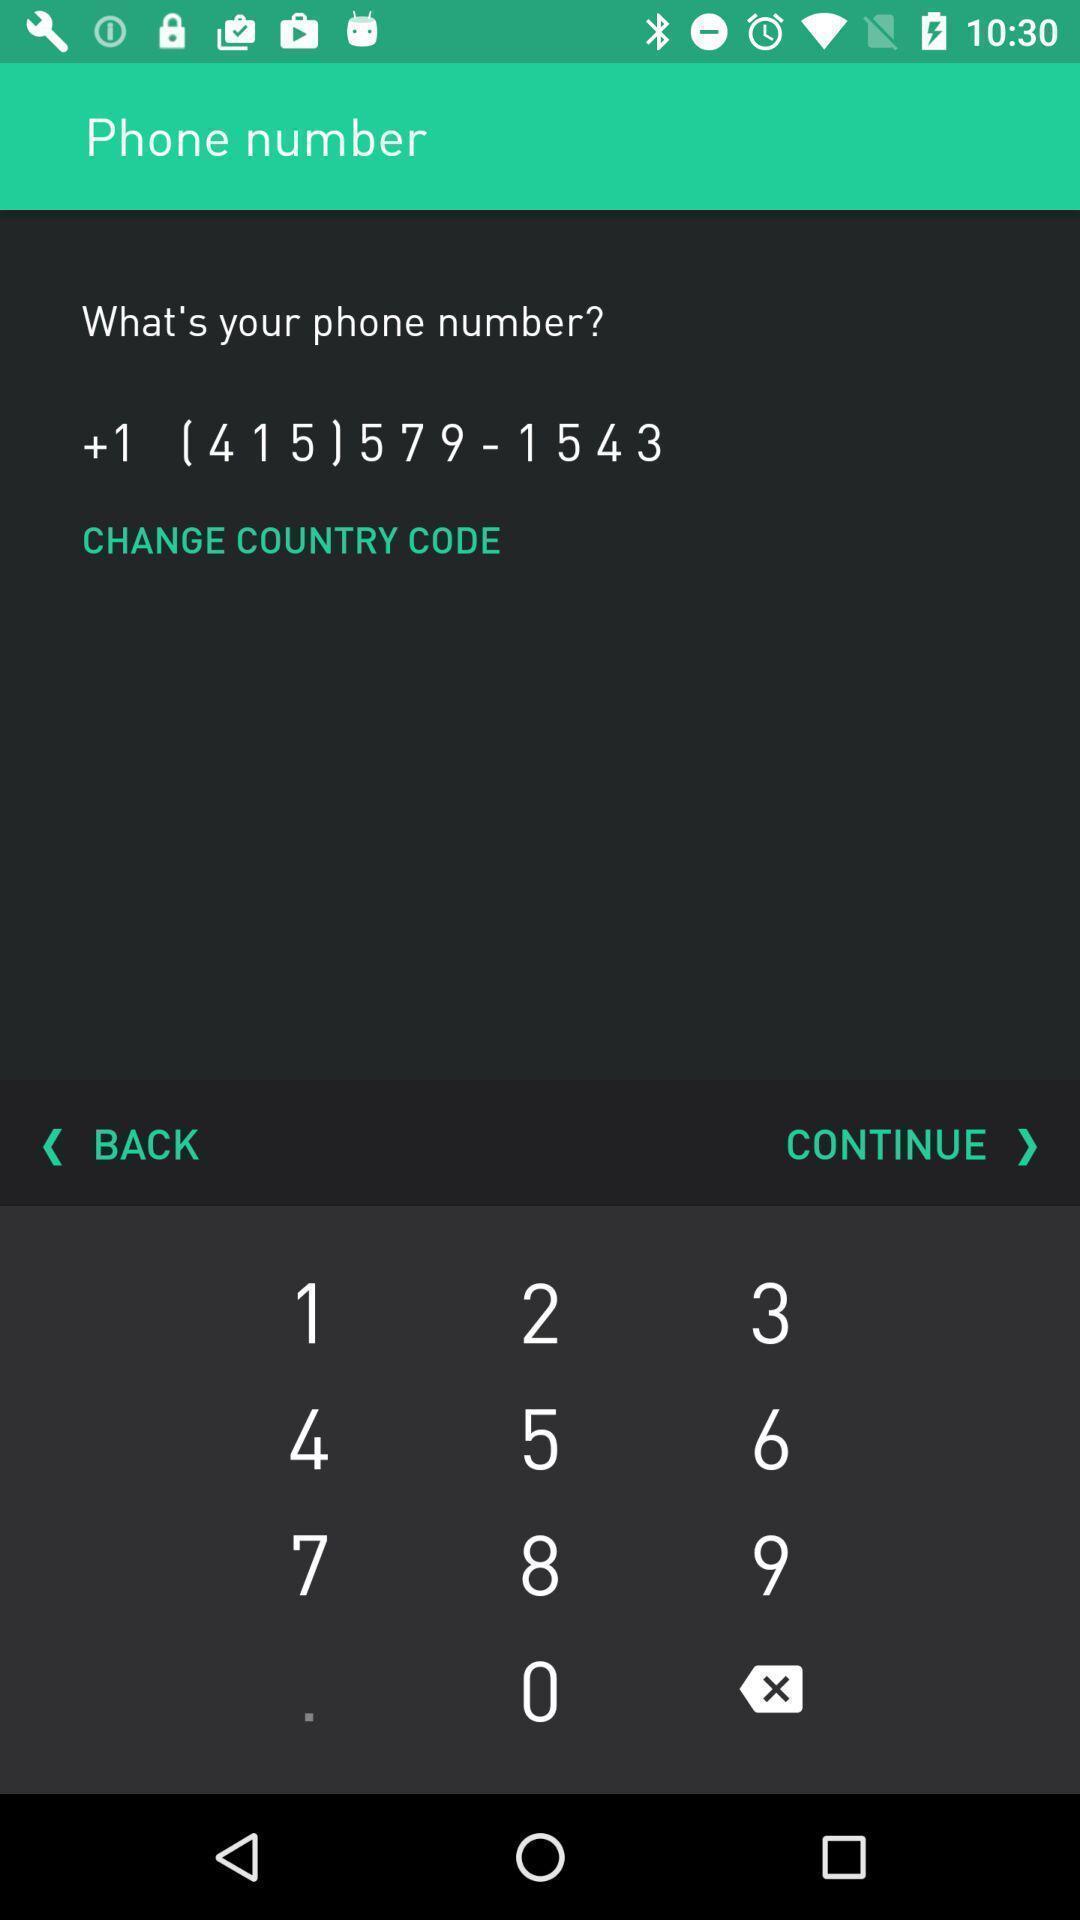What is the overall content of this screenshot? Screen displaying phone number with change country code option. 